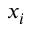Convert formula to latex. <formula><loc_0><loc_0><loc_500><loc_500>x _ { i }</formula> 